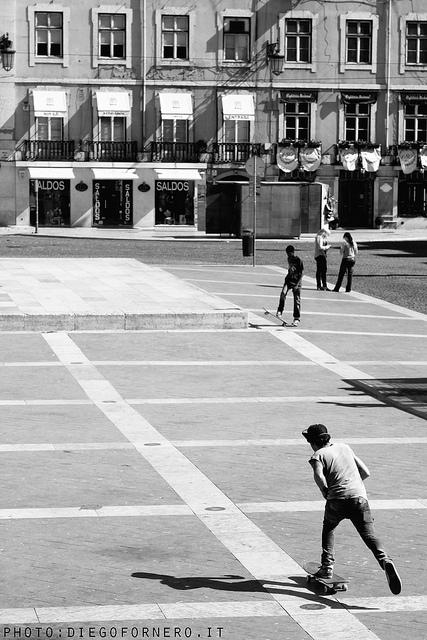Why is the boy kicking his leg back? skateboarding 